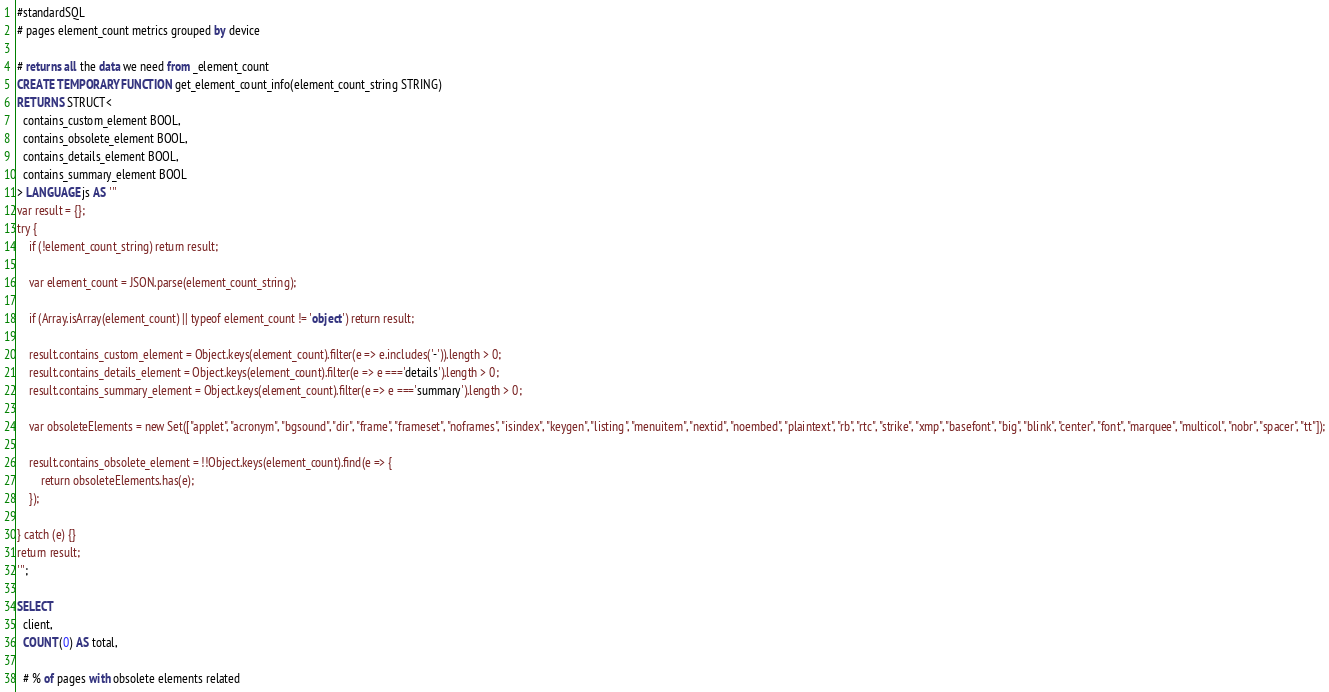Convert code to text. <code><loc_0><loc_0><loc_500><loc_500><_SQL_>#standardSQL
# pages element_count metrics grouped by device

# returns all the data we need from _element_count
CREATE TEMPORARY FUNCTION get_element_count_info(element_count_string STRING)
RETURNS STRUCT<
  contains_custom_element BOOL,
  contains_obsolete_element BOOL,
  contains_details_element BOOL,
  contains_summary_element BOOL
> LANGUAGE js AS '''
var result = {};
try {
    if (!element_count_string) return result;

    var element_count = JSON.parse(element_count_string);

    if (Array.isArray(element_count) || typeof element_count != 'object') return result;

    result.contains_custom_element = Object.keys(element_count).filter(e => e.includes('-')).length > 0;
    result.contains_details_element = Object.keys(element_count).filter(e => e ==='details').length > 0;
    result.contains_summary_element = Object.keys(element_count).filter(e => e ==='summary').length > 0;

    var obsoleteElements = new Set(["applet", "acronym", "bgsound", "dir", "frame", "frameset", "noframes", "isindex", "keygen", "listing", "menuitem", "nextid", "noembed", "plaintext", "rb", "rtc", "strike", "xmp", "basefont", "big", "blink", "center", "font", "marquee", "multicol", "nobr", "spacer", "tt"]);

    result.contains_obsolete_element = !!Object.keys(element_count).find(e => {
        return obsoleteElements.has(e);
    });

} catch (e) {}
return result;
''';

SELECT
  client,
  COUNT(0) AS total,

  # % of pages with obsolete elements related</code> 